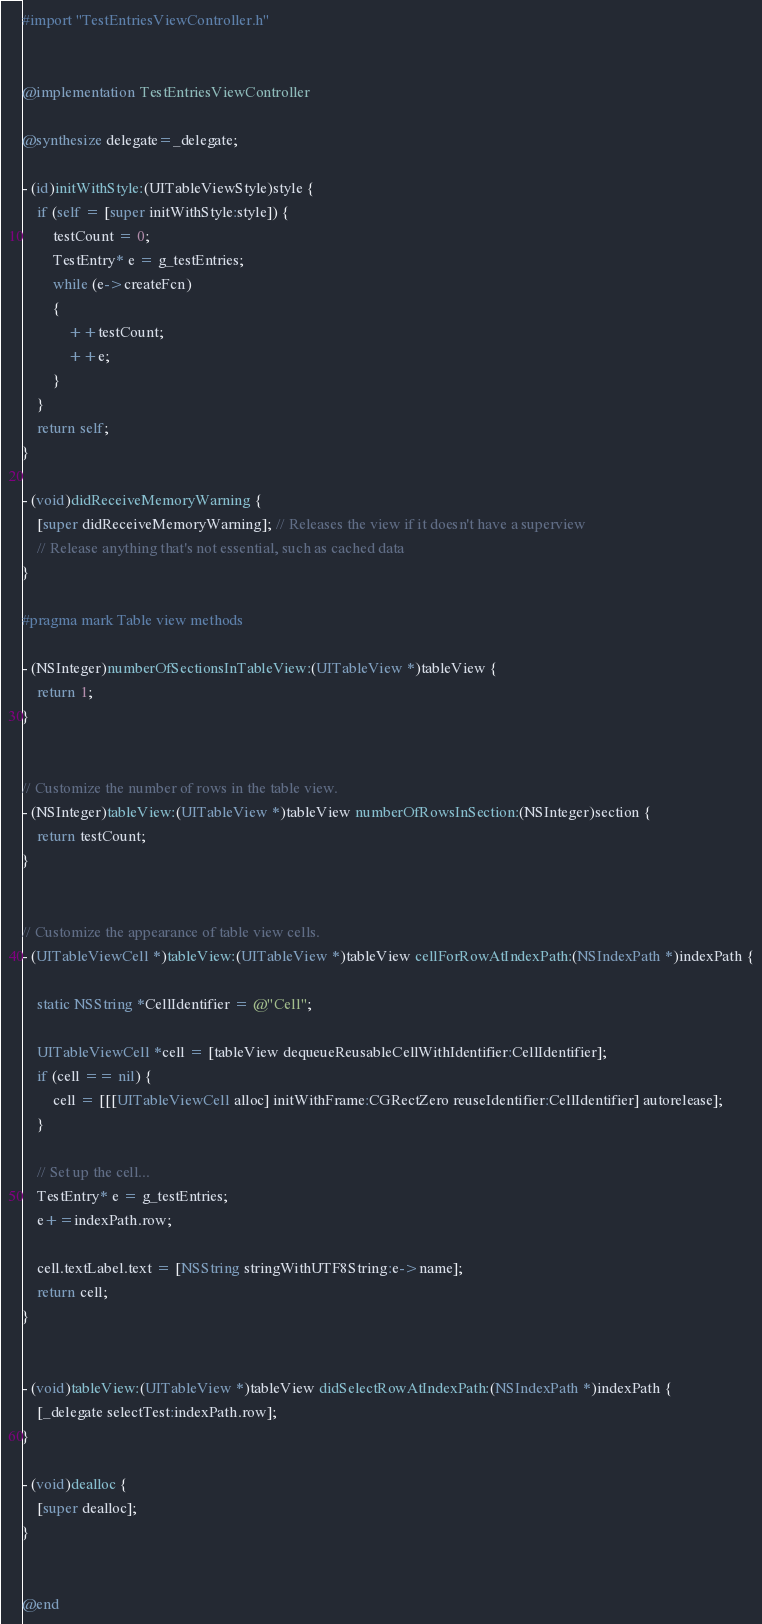Convert code to text. <code><loc_0><loc_0><loc_500><loc_500><_ObjectiveC_>
#import "TestEntriesViewController.h"


@implementation TestEntriesViewController

@synthesize delegate=_delegate;

- (id)initWithStyle:(UITableViewStyle)style {
	if (self = [super initWithStyle:style]) {
		testCount = 0;
		TestEntry* e = g_testEntries;
		while (e->createFcn)
		{
			++testCount;
			++e;
		}
    }
    return self;
}

- (void)didReceiveMemoryWarning {
    [super didReceiveMemoryWarning]; // Releases the view if it doesn't have a superview
    // Release anything that's not essential, such as cached data
}

#pragma mark Table view methods

- (NSInteger)numberOfSectionsInTableView:(UITableView *)tableView {
    return 1;
}


// Customize the number of rows in the table view.
- (NSInteger)tableView:(UITableView *)tableView numberOfRowsInSection:(NSInteger)section {
    return testCount;
}


// Customize the appearance of table view cells.
- (UITableViewCell *)tableView:(UITableView *)tableView cellForRowAtIndexPath:(NSIndexPath *)indexPath {
    
    static NSString *CellIdentifier = @"Cell";
    
    UITableViewCell *cell = [tableView dequeueReusableCellWithIdentifier:CellIdentifier];
    if (cell == nil) {
        cell = [[[UITableViewCell alloc] initWithFrame:CGRectZero reuseIdentifier:CellIdentifier] autorelease];
    }
    
    // Set up the cell...
	TestEntry* e = g_testEntries;
	e+=indexPath.row;

	cell.textLabel.text = [NSString stringWithUTF8String:e->name];
    return cell;
}


- (void)tableView:(UITableView *)tableView didSelectRowAtIndexPath:(NSIndexPath *)indexPath {
	[_delegate selectTest:indexPath.row];
}

- (void)dealloc {
    [super dealloc];
}


@end

</code> 